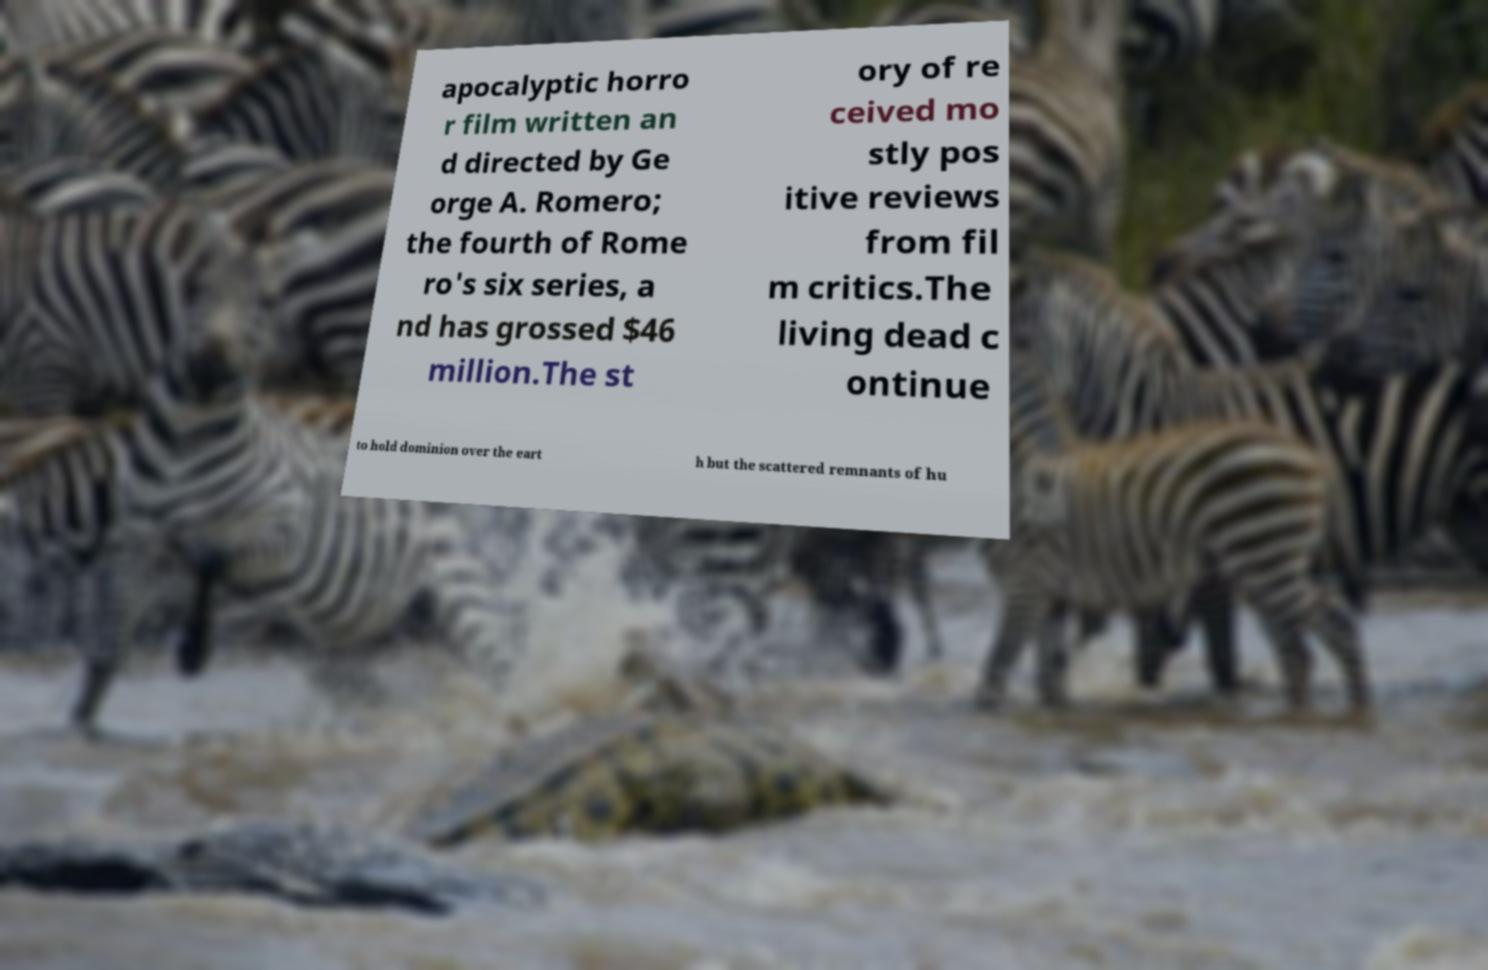Can you accurately transcribe the text from the provided image for me? apocalyptic horro r film written an d directed by Ge orge A. Romero; the fourth of Rome ro's six series, a nd has grossed $46 million.The st ory of re ceived mo stly pos itive reviews from fil m critics.The living dead c ontinue to hold dominion over the eart h but the scattered remnants of hu 